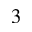Convert formula to latex. <formula><loc_0><loc_0><loc_500><loc_500>^ { 3 }</formula> 